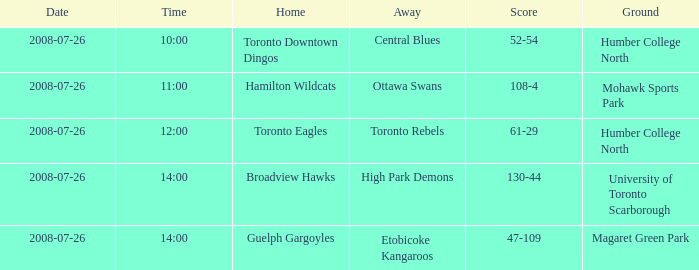The away high park demons was on which terrain? University of Toronto Scarborough. 